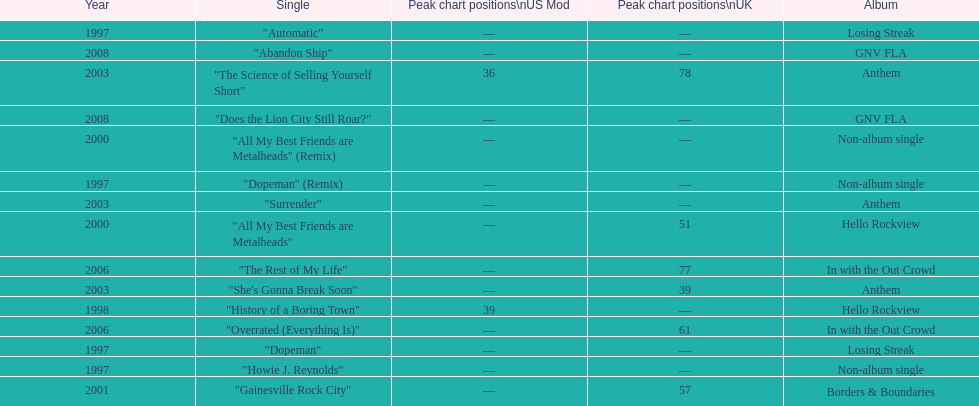Which year has the most singles? 1997. 